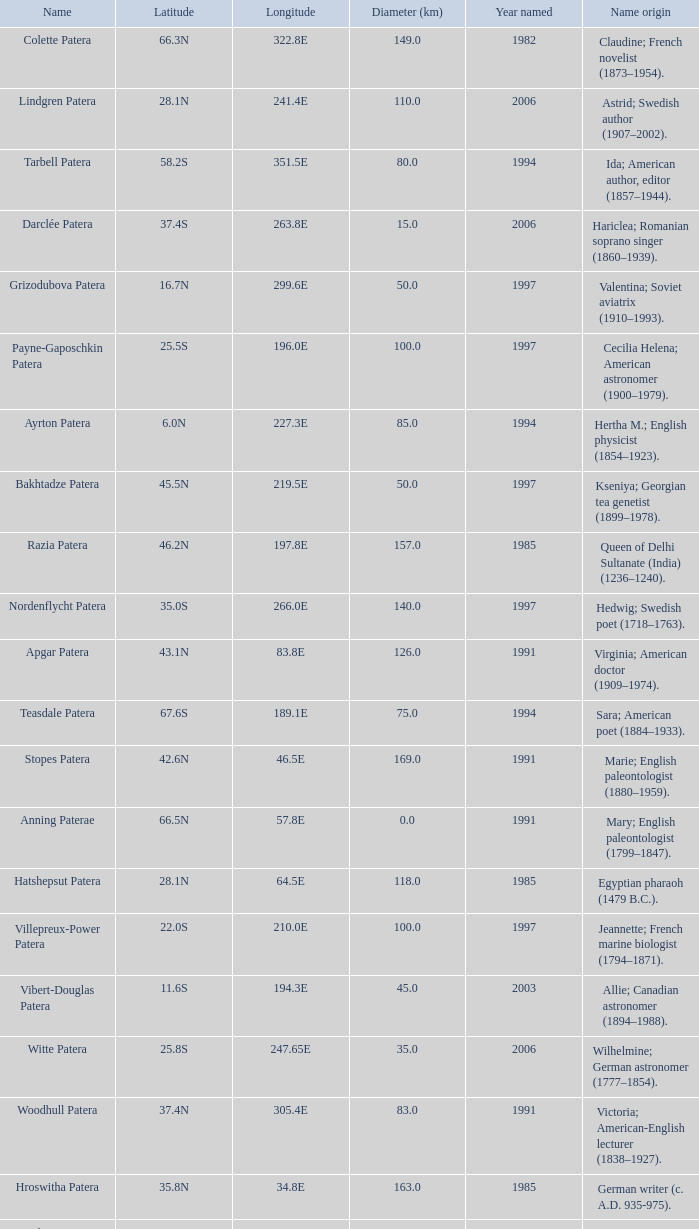What is the origin of the name of Keller Patera?  Helen; blind and deaf American writer (1880–1968). 